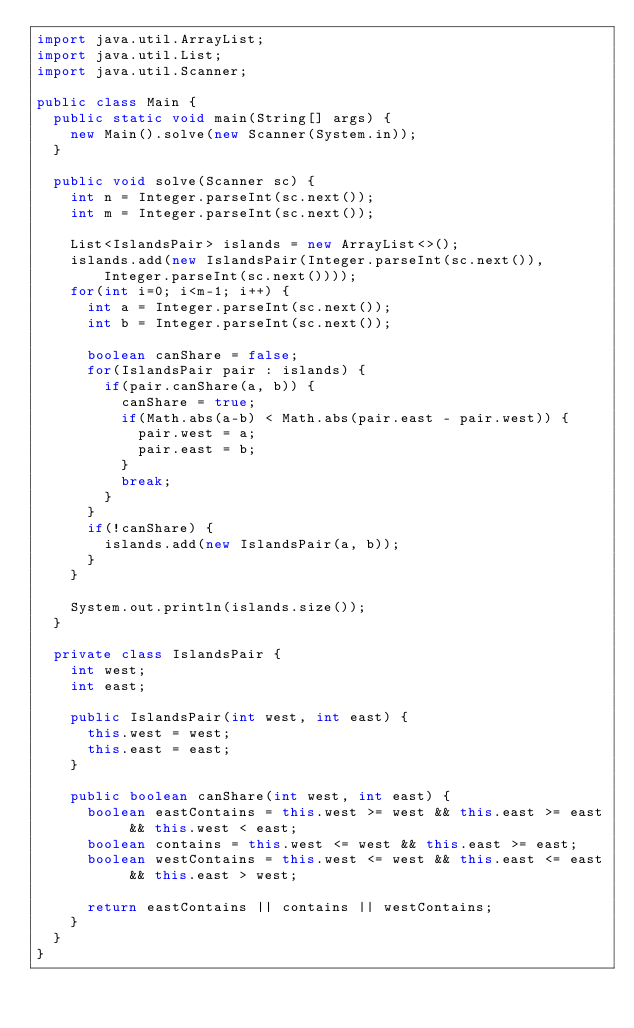Convert code to text. <code><loc_0><loc_0><loc_500><loc_500><_Java_>import java.util.ArrayList;
import java.util.List;
import java.util.Scanner;

public class Main {
	public static void main(String[] args) {
		new Main().solve(new Scanner(System.in));
	}

	public void solve(Scanner sc) {
		int n = Integer.parseInt(sc.next());
		int m = Integer.parseInt(sc.next());
		
		List<IslandsPair> islands = new ArrayList<>();
		islands.add(new IslandsPair(Integer.parseInt(sc.next()), Integer.parseInt(sc.next())));
		for(int i=0; i<m-1; i++) {
			int a = Integer.parseInt(sc.next());
			int b = Integer.parseInt(sc.next());
			
			boolean canShare = false;
			for(IslandsPair pair : islands) {
				if(pair.canShare(a, b)) {
					canShare = true;
					if(Math.abs(a-b) < Math.abs(pair.east - pair.west)) {
						pair.west = a;
						pair.east = b;
					}
					break;
				}
			}
			if(!canShare) {
				islands.add(new IslandsPair(a, b));
			}
		}
		
		System.out.println(islands.size());
	}
	
	private class IslandsPair {
		int west;
		int east;
		
		public IslandsPair(int west, int east) {
			this.west = west;
			this.east = east;
		}
		
		public boolean canShare(int west, int east) {
			boolean eastContains = this.west >= west && this.east >= east && this.west < east;
			boolean contains = this.west <= west && this.east >= east;
			boolean westContains = this.west <= west && this.east <= east && this.east > west;
			
			return eastContains || contains || westContains;
		}
	}
}</code> 